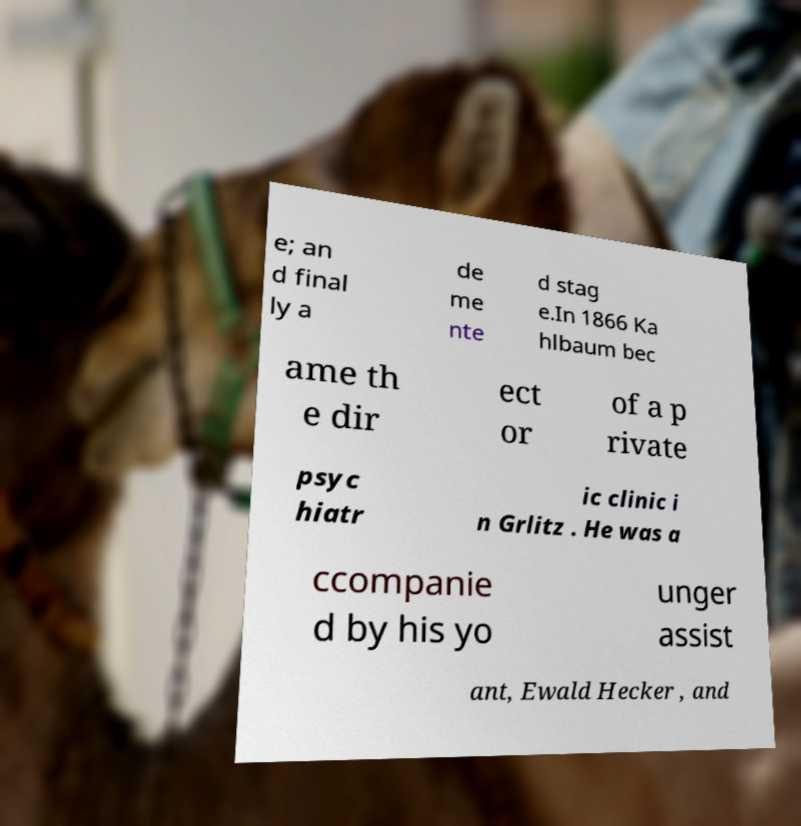There's text embedded in this image that I need extracted. Can you transcribe it verbatim? e; an d final ly a de me nte d stag e.In 1866 Ka hlbaum bec ame th e dir ect or of a p rivate psyc hiatr ic clinic i n Grlitz . He was a ccompanie d by his yo unger assist ant, Ewald Hecker , and 